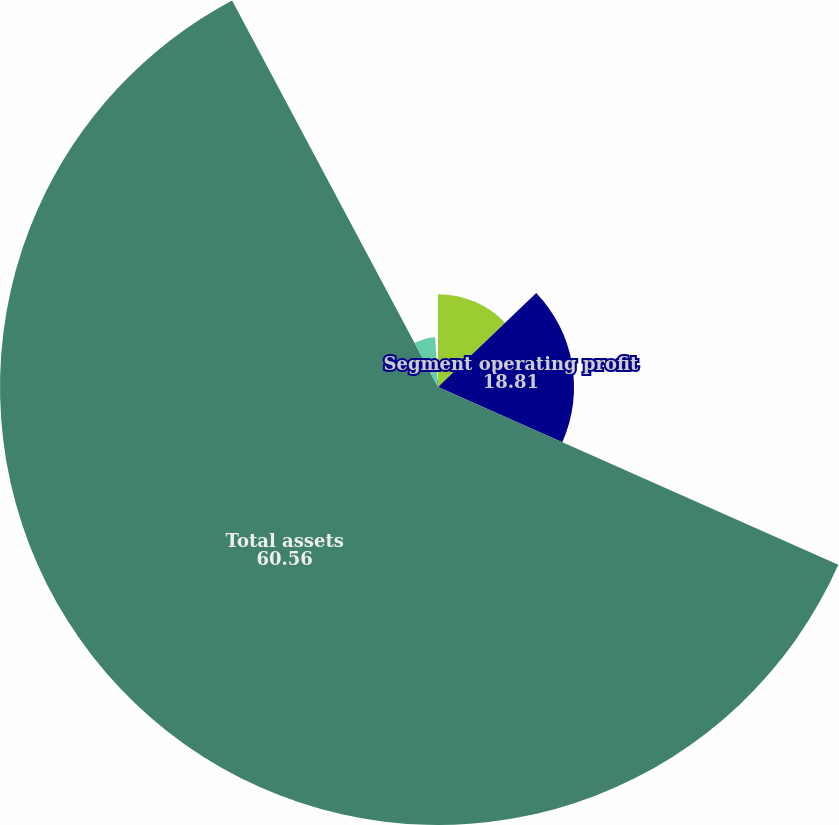Convert chart. <chart><loc_0><loc_0><loc_500><loc_500><pie_chart><fcel>Depreciation and amortization<fcel>Segment operating profit<fcel>Total assets<fcel>Additions to instruments<fcel>Additions to other property<nl><fcel>12.84%<fcel>18.81%<fcel>60.56%<fcel>6.88%<fcel>0.91%<nl></chart> 